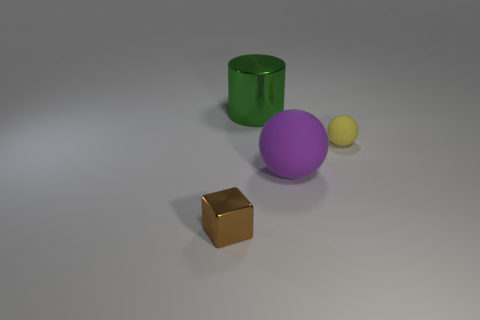Add 3 large gray matte cubes. How many objects exist? 7 Subtract all cubes. How many objects are left? 3 Add 2 large purple balls. How many large purple balls are left? 3 Add 2 gray balls. How many gray balls exist? 2 Subtract 0 brown cylinders. How many objects are left? 4 Subtract all gray rubber balls. Subtract all small brown cubes. How many objects are left? 3 